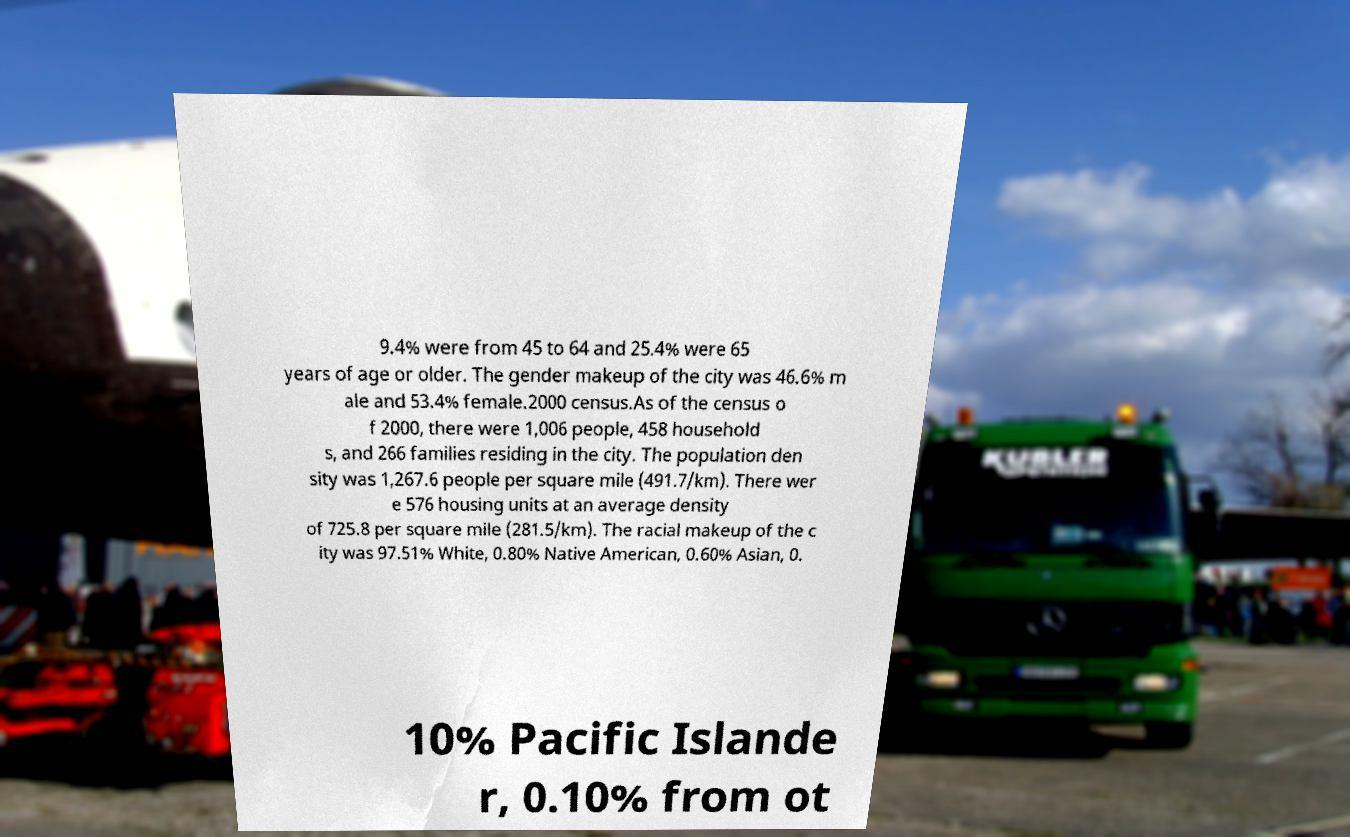There's text embedded in this image that I need extracted. Can you transcribe it verbatim? 9.4% were from 45 to 64 and 25.4% were 65 years of age or older. The gender makeup of the city was 46.6% m ale and 53.4% female.2000 census.As of the census o f 2000, there were 1,006 people, 458 household s, and 266 families residing in the city. The population den sity was 1,267.6 people per square mile (491.7/km). There wer e 576 housing units at an average density of 725.8 per square mile (281.5/km). The racial makeup of the c ity was 97.51% White, 0.80% Native American, 0.60% Asian, 0. 10% Pacific Islande r, 0.10% from ot 